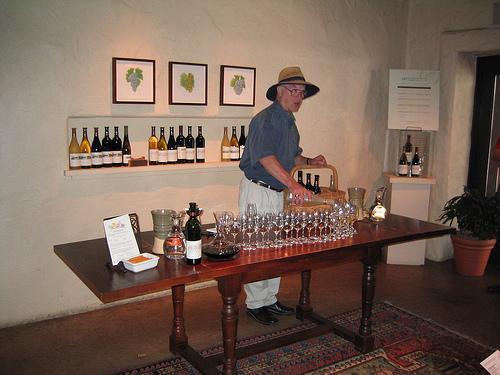How many people are in the picture?
Give a very brief answer. 1. 